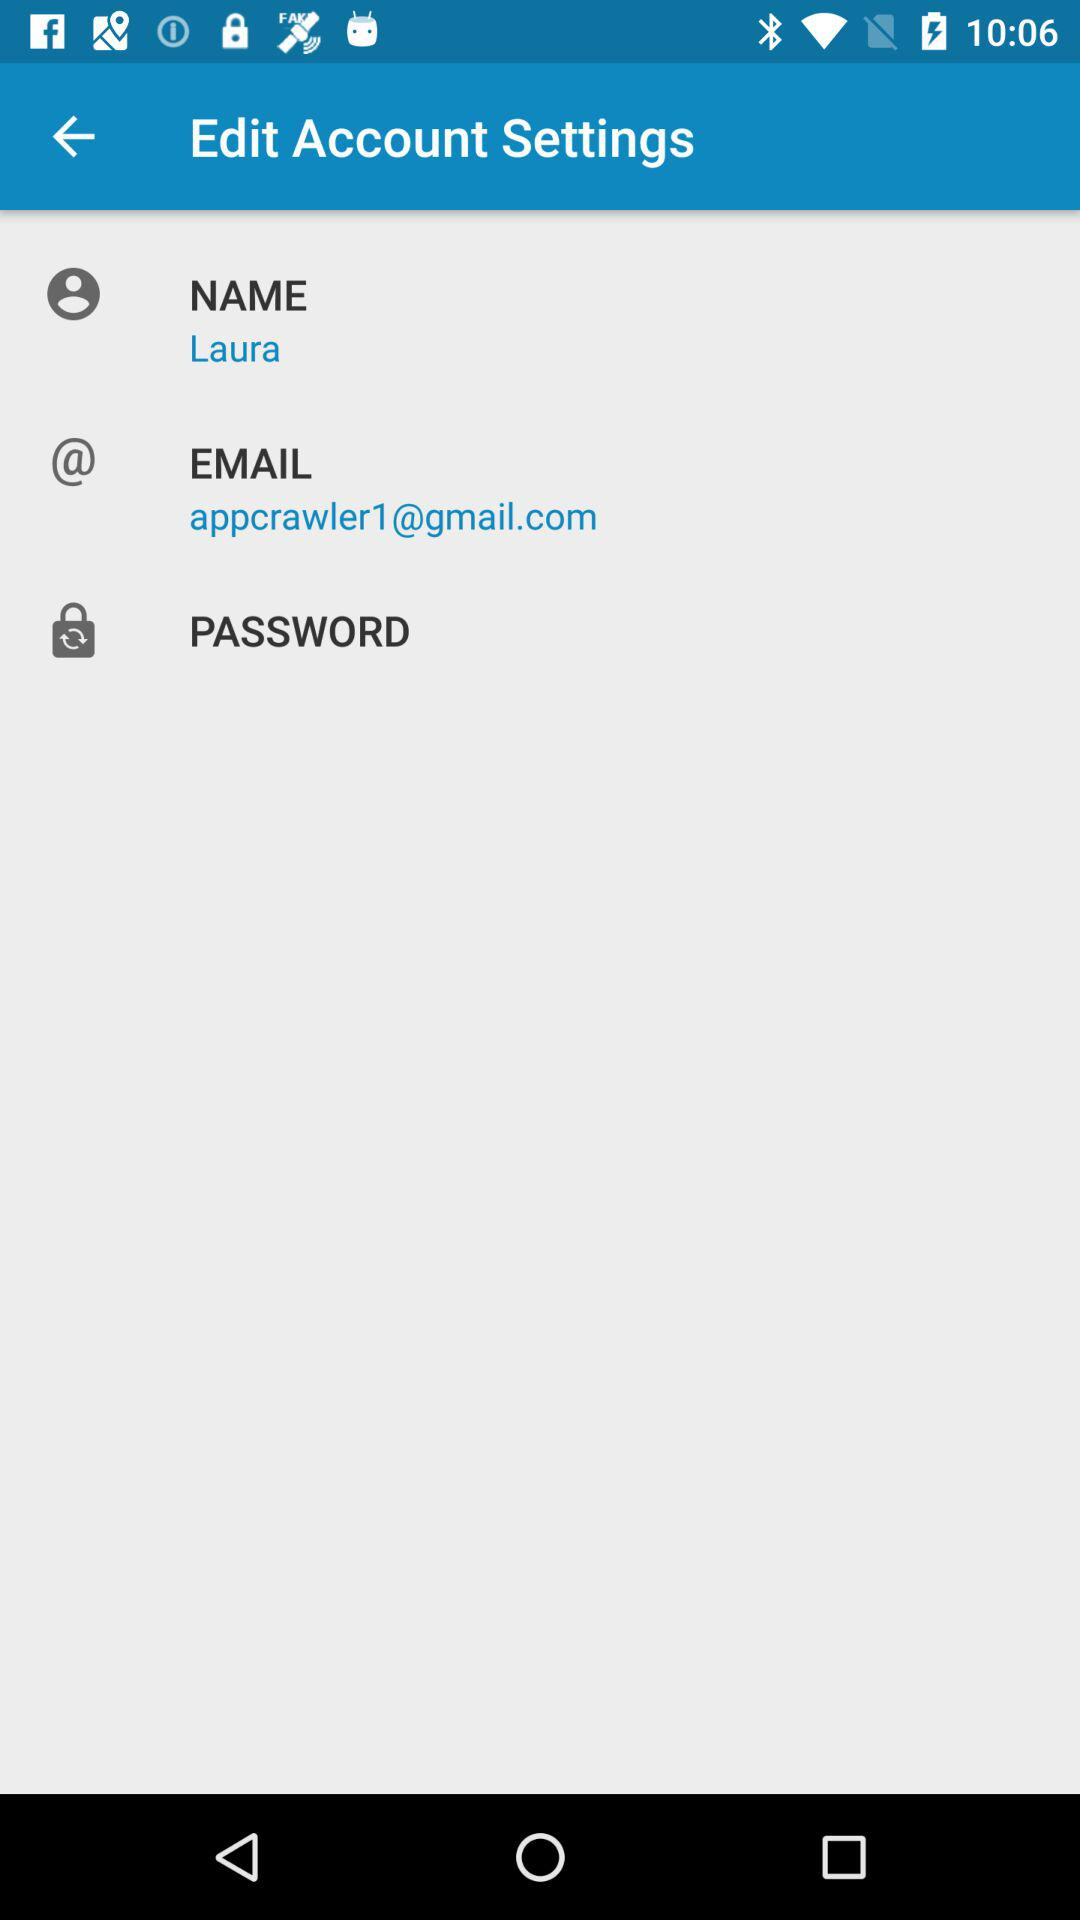What is the email address? The email address is appcrawler1@gmail.com. 